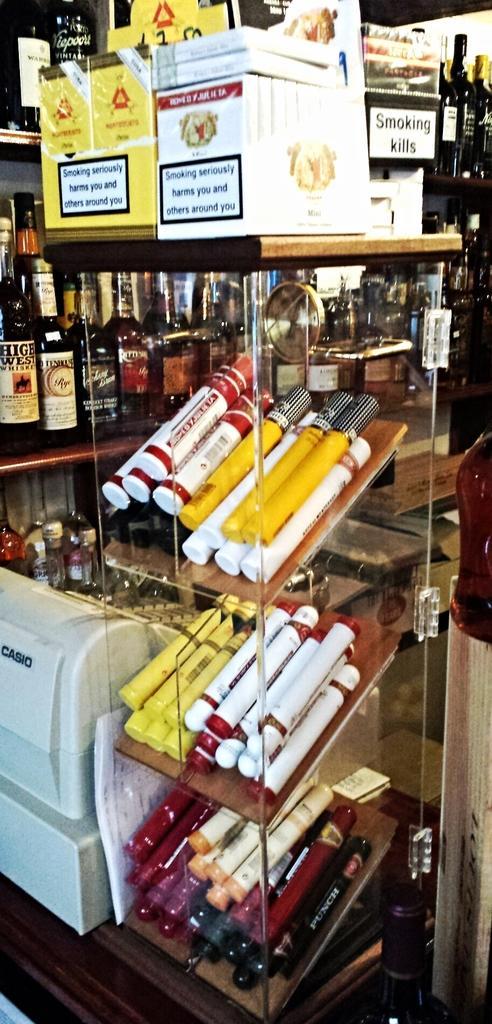Could you give a brief overview of what you see in this image? A glass with three shelves in it. On the shelf there are some color objects. Behind the glass there is a cupboard with many bottles and many boxes. To the right there is a object. TO the left side there is a printer. 